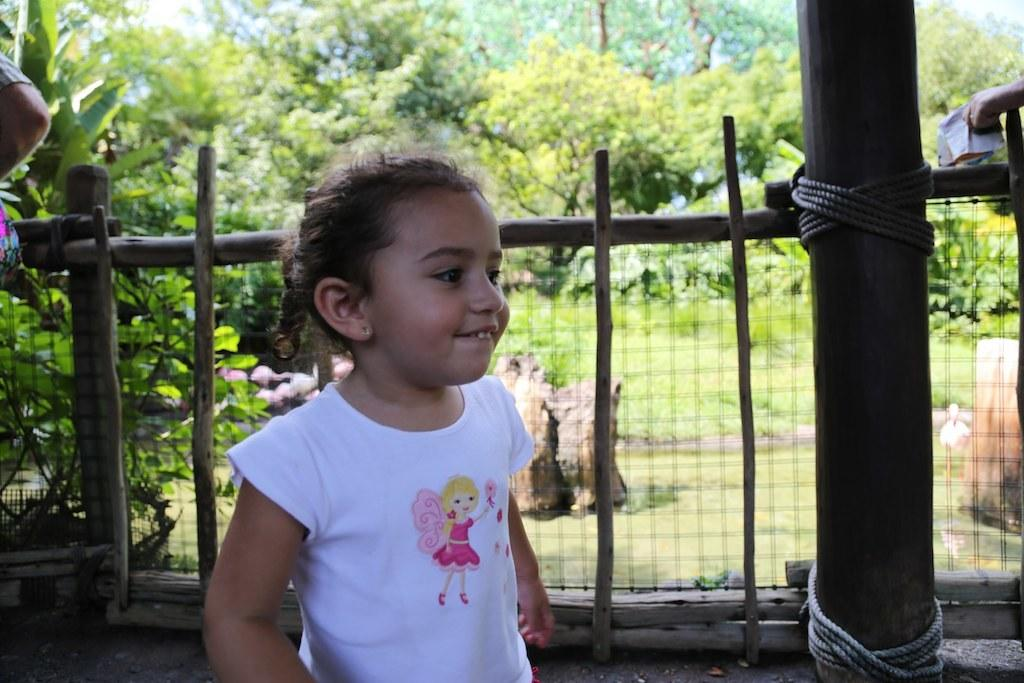Who is the main subject in the foreground of the image? There is a girl in the foreground of the image. What can be seen in the background of the image? In the background of the image, there is a fence, pillars, a person, grass, trees, and the sky. Can you describe the setting of the image? The image appears to be taken outdoors, with grass, trees, and a fence visible in the background. The presence of the sky suggests it was taken during the day. What type of action is the banana performing in the image? There is no banana present in the image, so it cannot perform any actions. How does the stomach of the girl in the image feel? The image does not provide any information about the girl's feelings or emotions, including her stomach. 